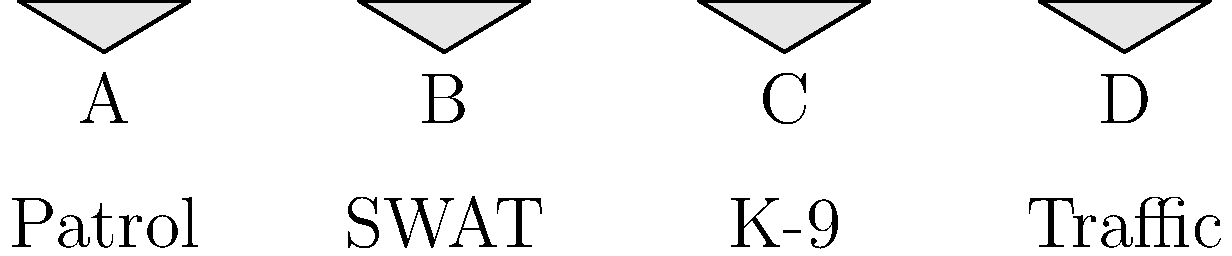Match the police vehicle types (Patrol, SWAT, K-9, Traffic) with their corresponding icon (A, B, C, D) based on their primary functions in law enforcement. Which icon represents the SWAT vehicle? To identify the SWAT vehicle icon, let's analyze each vehicle type and its function:

1. Patrol: This is the most common police vehicle, used for general policing duties and responding to calls. It's typically a standard sedan or SUV.

2. SWAT (Special Weapons and Tactics): These vehicles are larger, more heavily armored, and designed for high-risk operations. They often resemble military vehicles or large vans.

3. K-9: These vehicles are specially equipped to transport police dogs. They usually have kennels or cages in the back and are often based on SUVs or vans.

4. Traffic: These vehicles are used for traffic enforcement and accident response. They're often similar to patrol cars but may have additional visibility features.

Looking at the icons:

A: Simple car shape, likely representing a standard patrol vehicle.
B: Larger, more box-like shape, suggesting a larger, more specialized vehicle like a SWAT van.
C: Similar to A, but could represent a slightly larger vehicle, possibly for K-9 units.
D: Another car-like shape, potentially representing a traffic enforcement vehicle.

Based on this analysis, the icon that best represents the SWAT vehicle is B, as it depicts a larger, more specialized vehicle suitable for SWAT operations.
Answer: B 